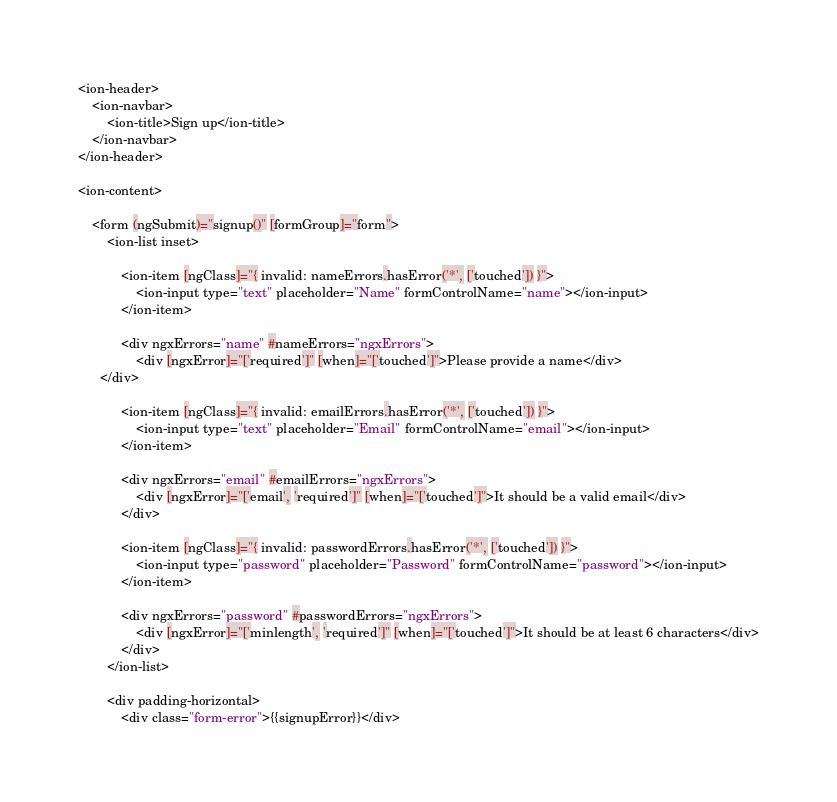Convert code to text. <code><loc_0><loc_0><loc_500><loc_500><_HTML_><ion-header>
	<ion-navbar>
		<ion-title>Sign up</ion-title>
	</ion-navbar>
</ion-header>

<ion-content>

	<form (ngSubmit)="signup()" [formGroup]="form">
		<ion-list inset>

			<ion-item [ngClass]="{ invalid: nameErrors.hasError('*', ['touched']) }">
				<ion-input type="text" placeholder="Name" formControlName="name"></ion-input>
			</ion-item>

			<div ngxErrors="name" #nameErrors="ngxErrors">
				<div [ngxError]="['required']" [when]="['touched']">Please provide a name</div>
      </div>

			<ion-item [ngClass]="{ invalid: emailErrors.hasError('*', ['touched']) }">
				<ion-input type="text" placeholder="Email" formControlName="email"></ion-input>
			</ion-item>

			<div ngxErrors="email" #emailErrors="ngxErrors">
				<div [ngxError]="['email', 'required']" [when]="['touched']">It should be a valid email</div>
			</div>

			<ion-item [ngClass]="{ invalid: passwordErrors.hasError('*', ['touched']) }">
				<ion-input type="password" placeholder="Password" formControlName="password"></ion-input>
			</ion-item>

			<div ngxErrors="password" #passwordErrors="ngxErrors">
				<div [ngxError]="['minlength', 'required']" [when]="['touched']">It should be at least 6 characters</div>
			</div>
		</ion-list>

		<div padding-horizontal>
			<div class="form-error">{{signupError}}</div>
</code> 